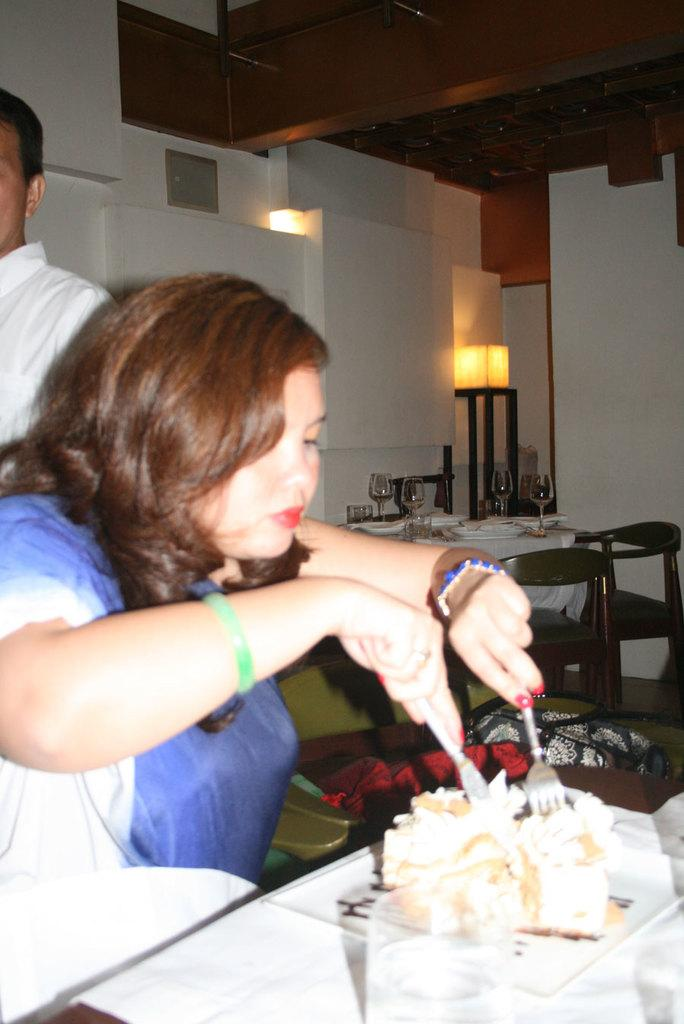Who is the main subject in the image? There is a woman in the image. What is the woman doing in the image? The woman is sitting on a chair and eating food. How is the woman eating the food? The woman is using a fork to eat the food. What type of bear can be seen in the image? There is no bear present in the image; it features a woman sitting on a chair and eating food. How much salt is on the woman's hair in the image? There is no salt or mention of hair in the image; it only shows a woman eating food with a fork. 